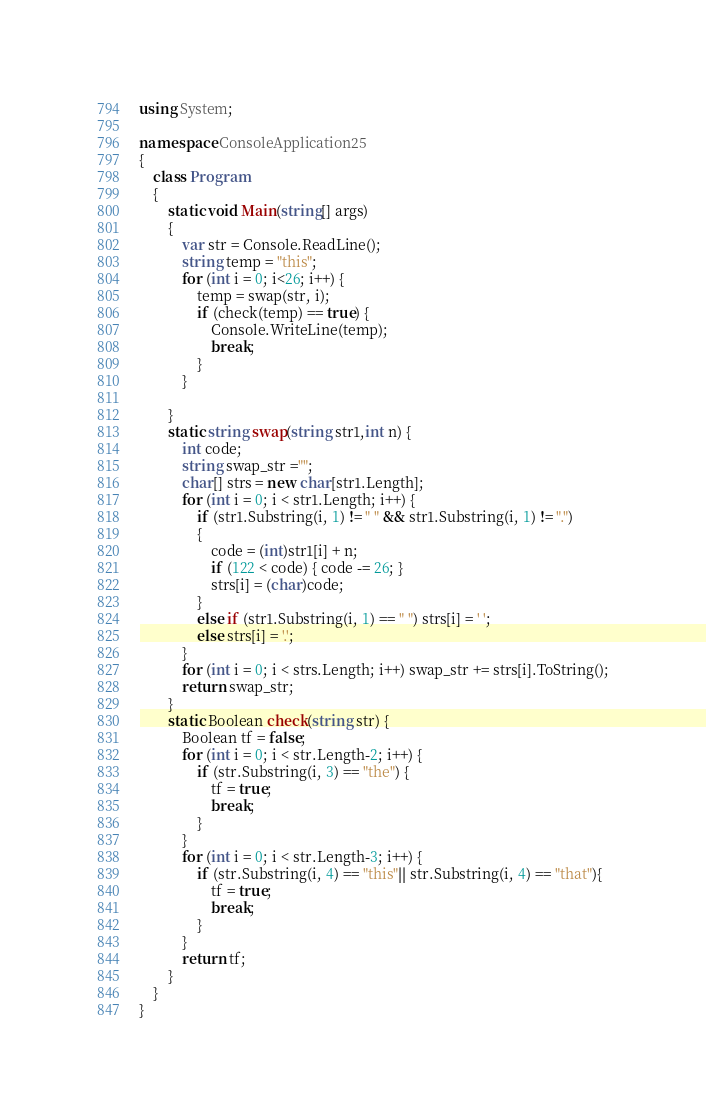Convert code to text. <code><loc_0><loc_0><loc_500><loc_500><_C#_>using System;

namespace ConsoleApplication25
{
    class Program
    {
        static void Main(string[] args)
        {
            var str = Console.ReadLine();
            string temp = "this";
            for (int i = 0; i<26; i++) {
                temp = swap(str, i);
                if (check(temp) == true) {
                    Console.WriteLine(temp);
                    break;
                }
            }
            
        }
        static string swap(string str1,int n) {
            int code;
            string swap_str ="";
            char[] strs = new char[str1.Length];
            for (int i = 0; i < str1.Length; i++) {
                if (str1.Substring(i, 1) != " " && str1.Substring(i, 1) != ".")
                {
                    code = (int)str1[i] + n;
                    if (122 < code) { code -= 26; }
                    strs[i] = (char)code;
                }
                else if (str1.Substring(i, 1) == " ") strs[i] = ' ';
                else strs[i] = '.';
            }
            for (int i = 0; i < strs.Length; i++) swap_str += strs[i].ToString();
            return swap_str;
        }
        static Boolean check(string str) {
            Boolean tf = false;
            for (int i = 0; i < str.Length-2; i++) {
                if (str.Substring(i, 3) == "the") {
                    tf = true;
                    break;
                }
            }
            for (int i = 0; i < str.Length-3; i++) {
                if (str.Substring(i, 4) == "this"|| str.Substring(i, 4) == "that"){
                    tf = true;
                    break;
                }
            }
            return tf;
        }
    }
}</code> 